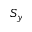Convert formula to latex. <formula><loc_0><loc_0><loc_500><loc_500>S _ { y }</formula> 